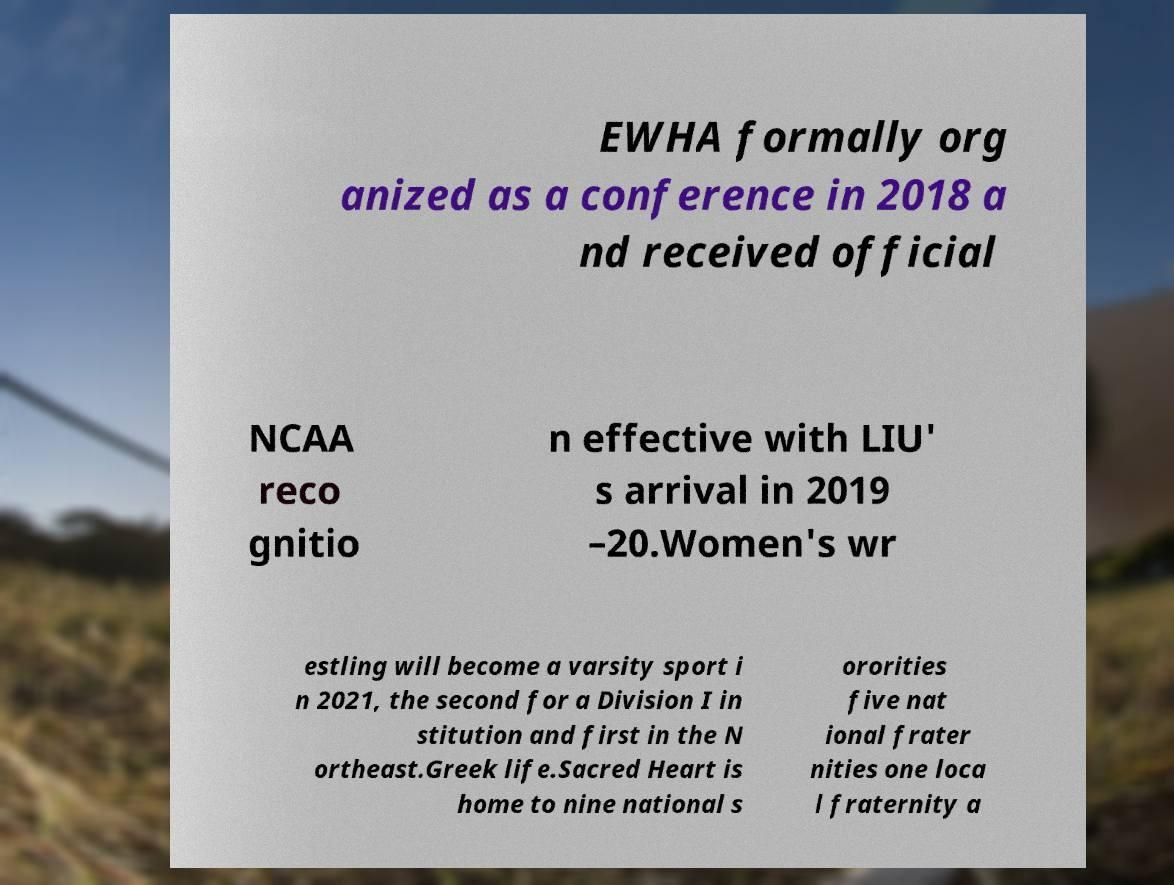I need the written content from this picture converted into text. Can you do that? EWHA formally org anized as a conference in 2018 a nd received official NCAA reco gnitio n effective with LIU' s arrival in 2019 –20.Women's wr estling will become a varsity sport i n 2021, the second for a Division I in stitution and first in the N ortheast.Greek life.Sacred Heart is home to nine national s ororities five nat ional frater nities one loca l fraternity a 